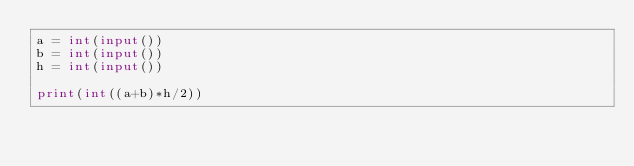Convert code to text. <code><loc_0><loc_0><loc_500><loc_500><_Python_>a = int(input())
b = int(input())
h = int(input())

print(int((a+b)*h/2))</code> 